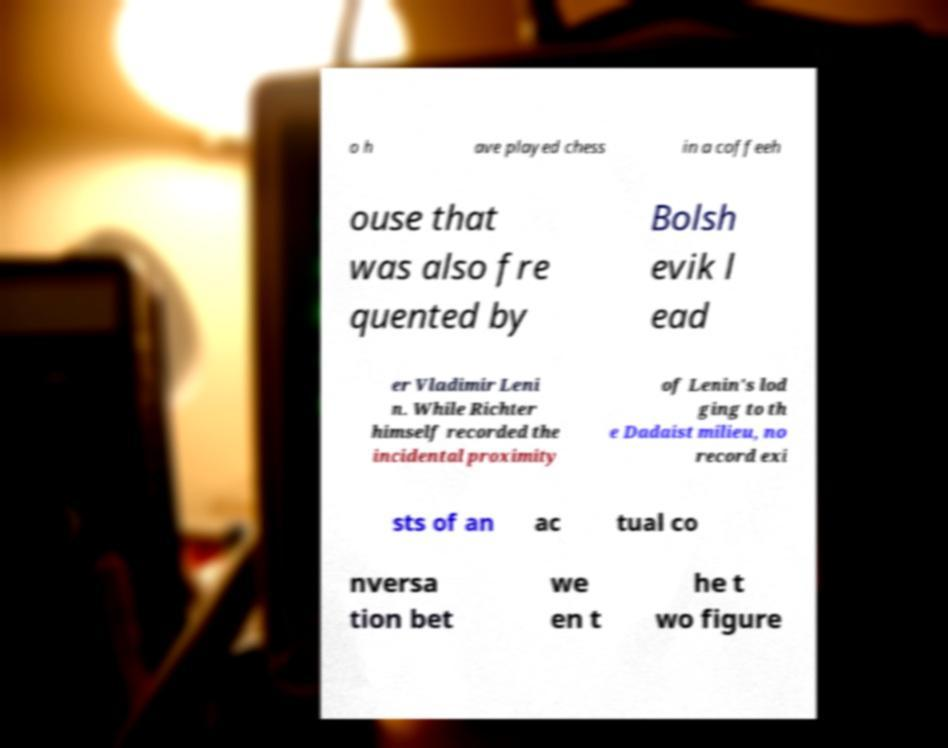Can you read and provide the text displayed in the image?This photo seems to have some interesting text. Can you extract and type it out for me? o h ave played chess in a coffeeh ouse that was also fre quented by Bolsh evik l ead er Vladimir Leni n. While Richter himself recorded the incidental proximity of Lenin's lod ging to th e Dadaist milieu, no record exi sts of an ac tual co nversa tion bet we en t he t wo figure 